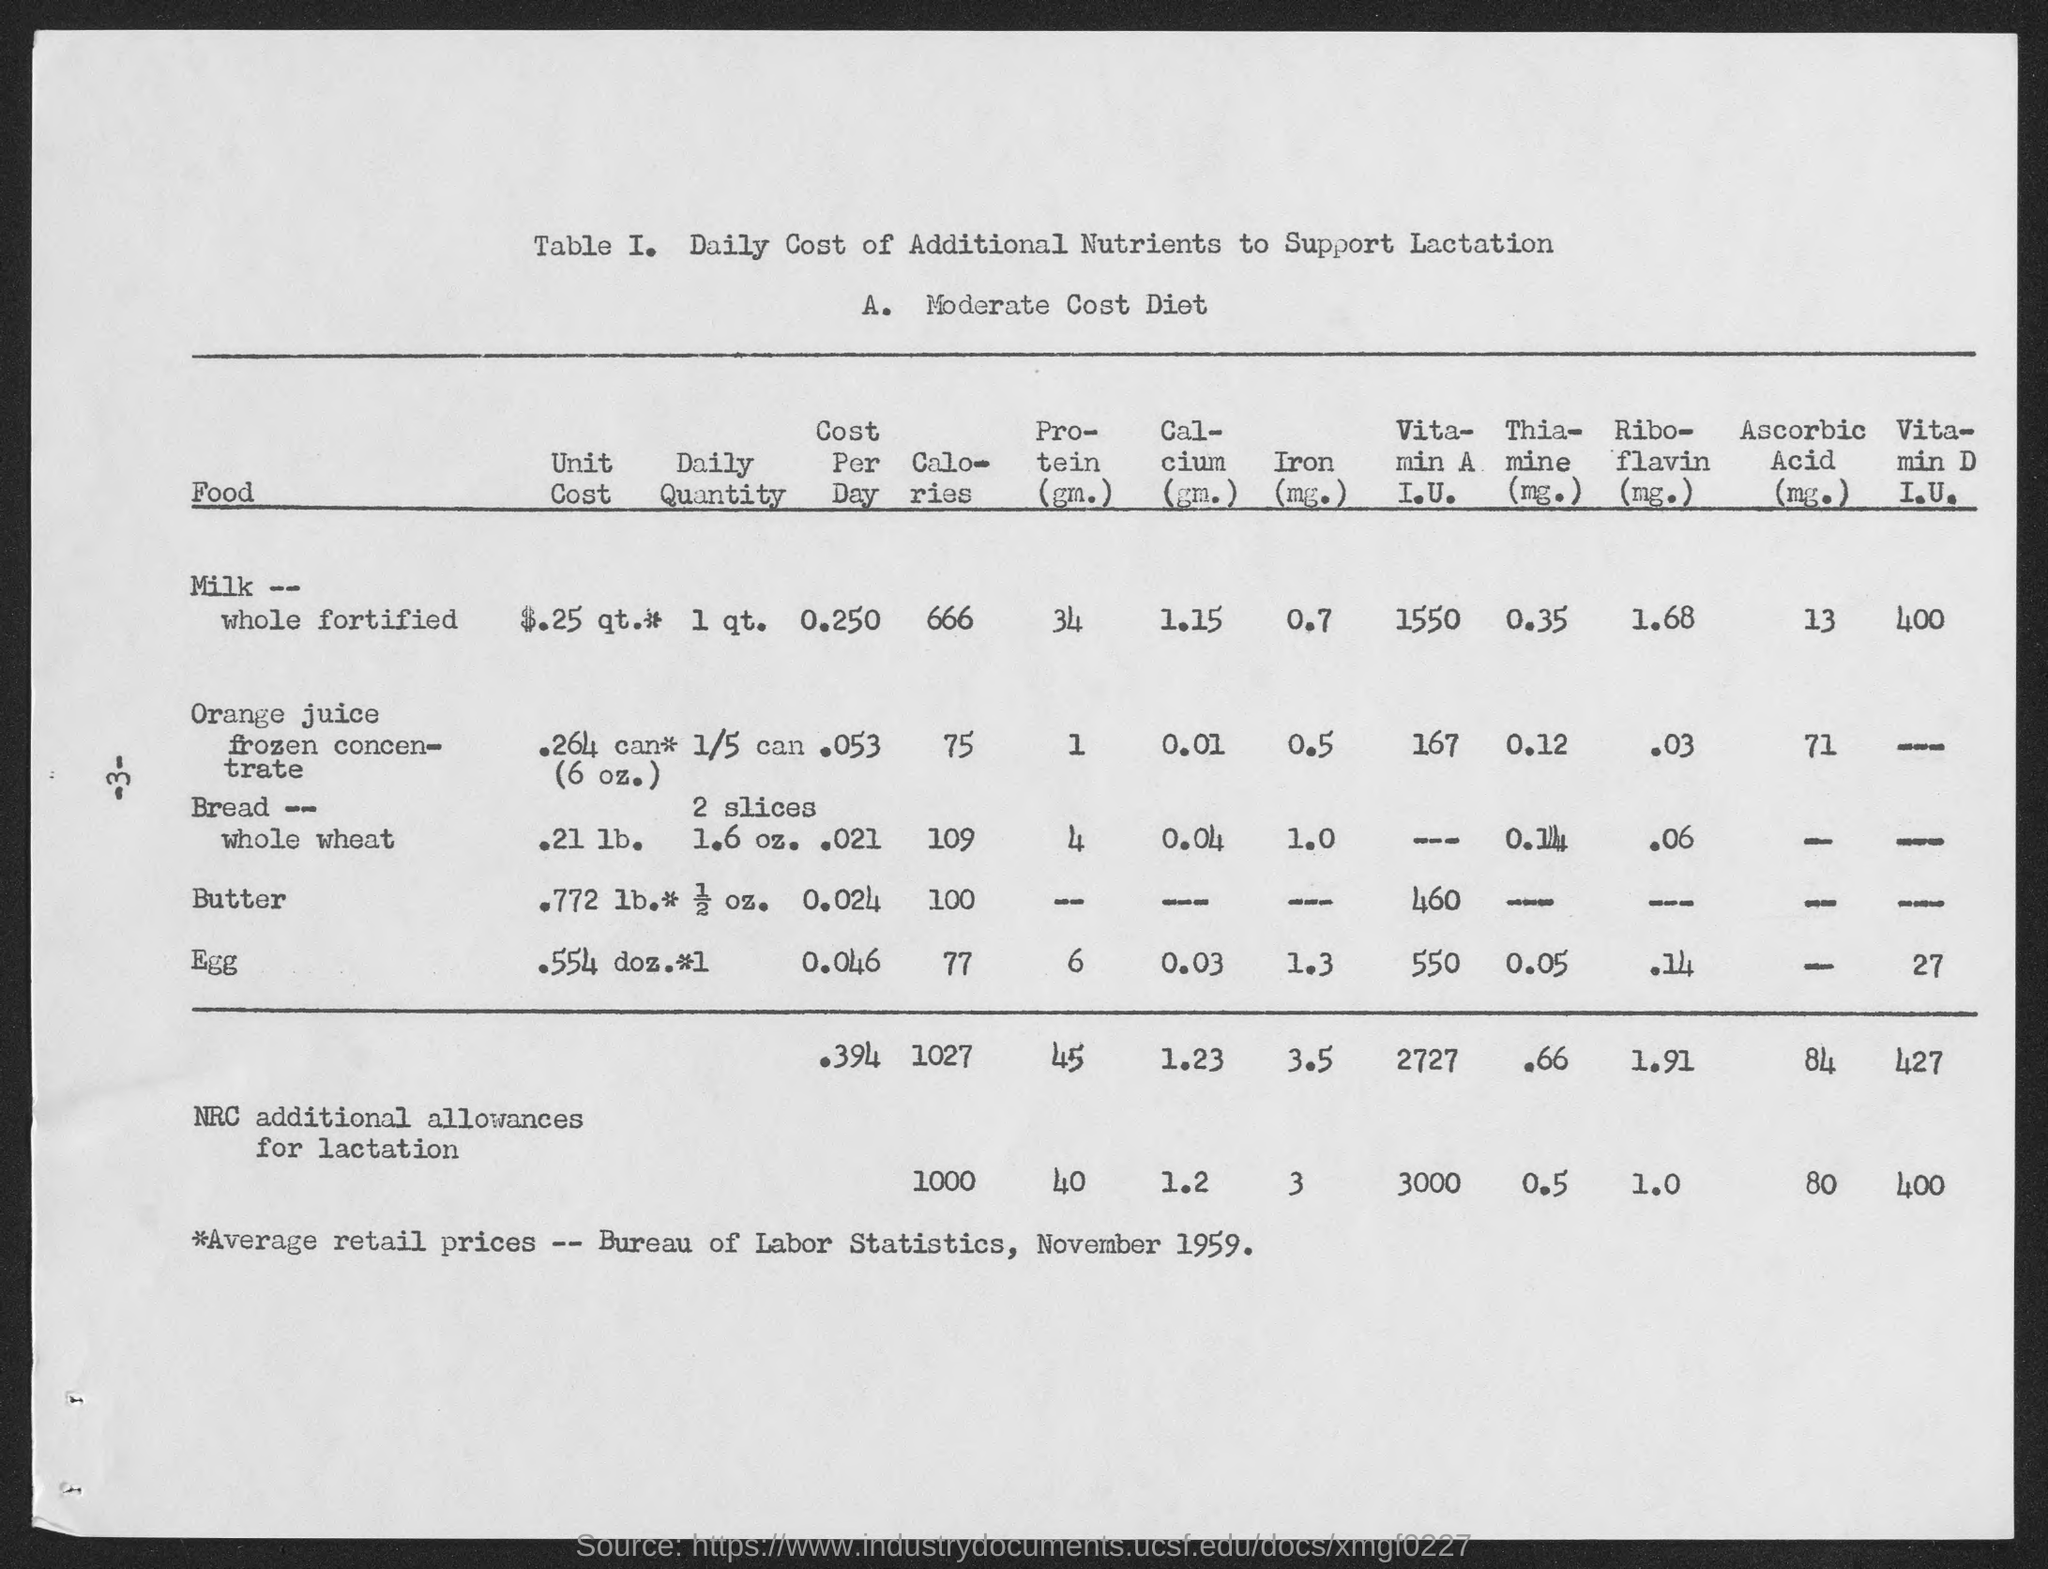Identify some key points in this picture. The calories for orange juice frozen concentrate are 75 per serving. The caloric content of butter is 100. The protein content of fortified whole milk is 34 grams per serving. The calories for whole milk fortified with vitamins A and D are 666... There are 6 grams of protein in an egg. 